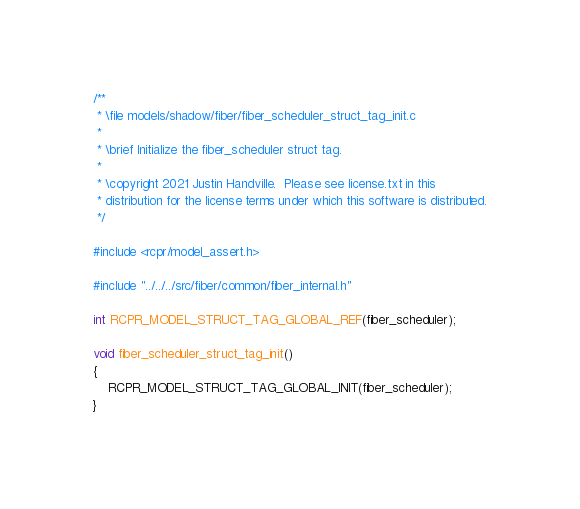Convert code to text. <code><loc_0><loc_0><loc_500><loc_500><_C_>/**
 * \file models/shadow/fiber/fiber_scheduler_struct_tag_init.c
 *
 * \brief Initialize the fiber_scheduler struct tag.
 *
 * \copyright 2021 Justin Handville.  Please see license.txt in this
 * distribution for the license terms under which this software is distributed.
 */

#include <rcpr/model_assert.h>

#include "../../../src/fiber/common/fiber_internal.h"

int RCPR_MODEL_STRUCT_TAG_GLOBAL_REF(fiber_scheduler);

void fiber_scheduler_struct_tag_init()
{
    RCPR_MODEL_STRUCT_TAG_GLOBAL_INIT(fiber_scheduler);
}
</code> 